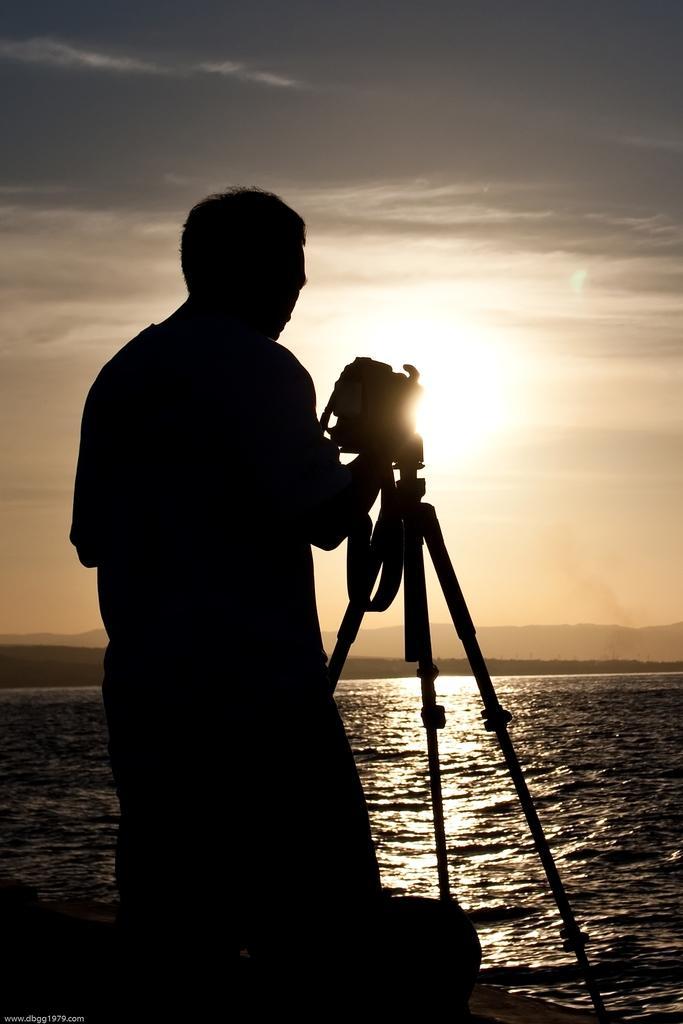Please provide a concise description of this image. In this image I can see the shadow of a person holding a camera and I can see the camera stand. In the background I can see water, few mountains, the sky and the sun. 